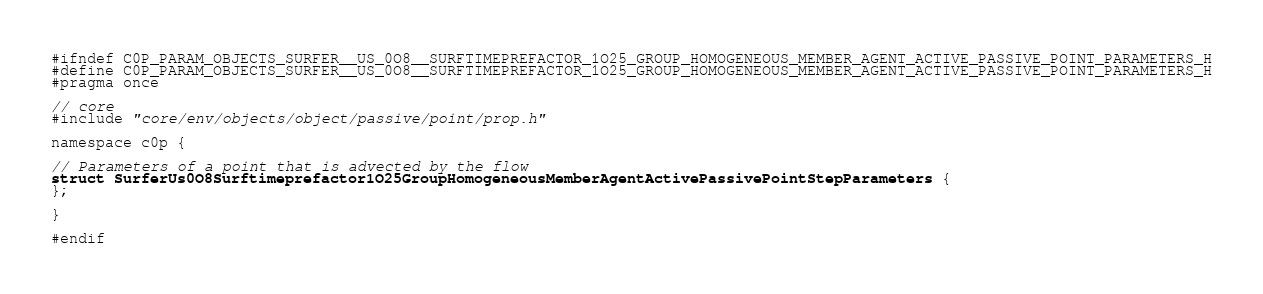<code> <loc_0><loc_0><loc_500><loc_500><_C_>#ifndef C0P_PARAM_OBJECTS_SURFER__US_0O8__SURFTIMEPREFACTOR_1O25_GROUP_HOMOGENEOUS_MEMBER_AGENT_ACTIVE_PASSIVE_POINT_PARAMETERS_H
#define C0P_PARAM_OBJECTS_SURFER__US_0O8__SURFTIMEPREFACTOR_1O25_GROUP_HOMOGENEOUS_MEMBER_AGENT_ACTIVE_PASSIVE_POINT_PARAMETERS_H
#pragma once

// core
#include "core/env/objects/object/passive/point/prop.h"

namespace c0p {

// Parameters of a point that is advected by the flow
struct SurferUs0O8Surftimeprefactor1O25GroupHomogeneousMemberAgentActivePassivePointStepParameters {
};

}

#endif
</code> 